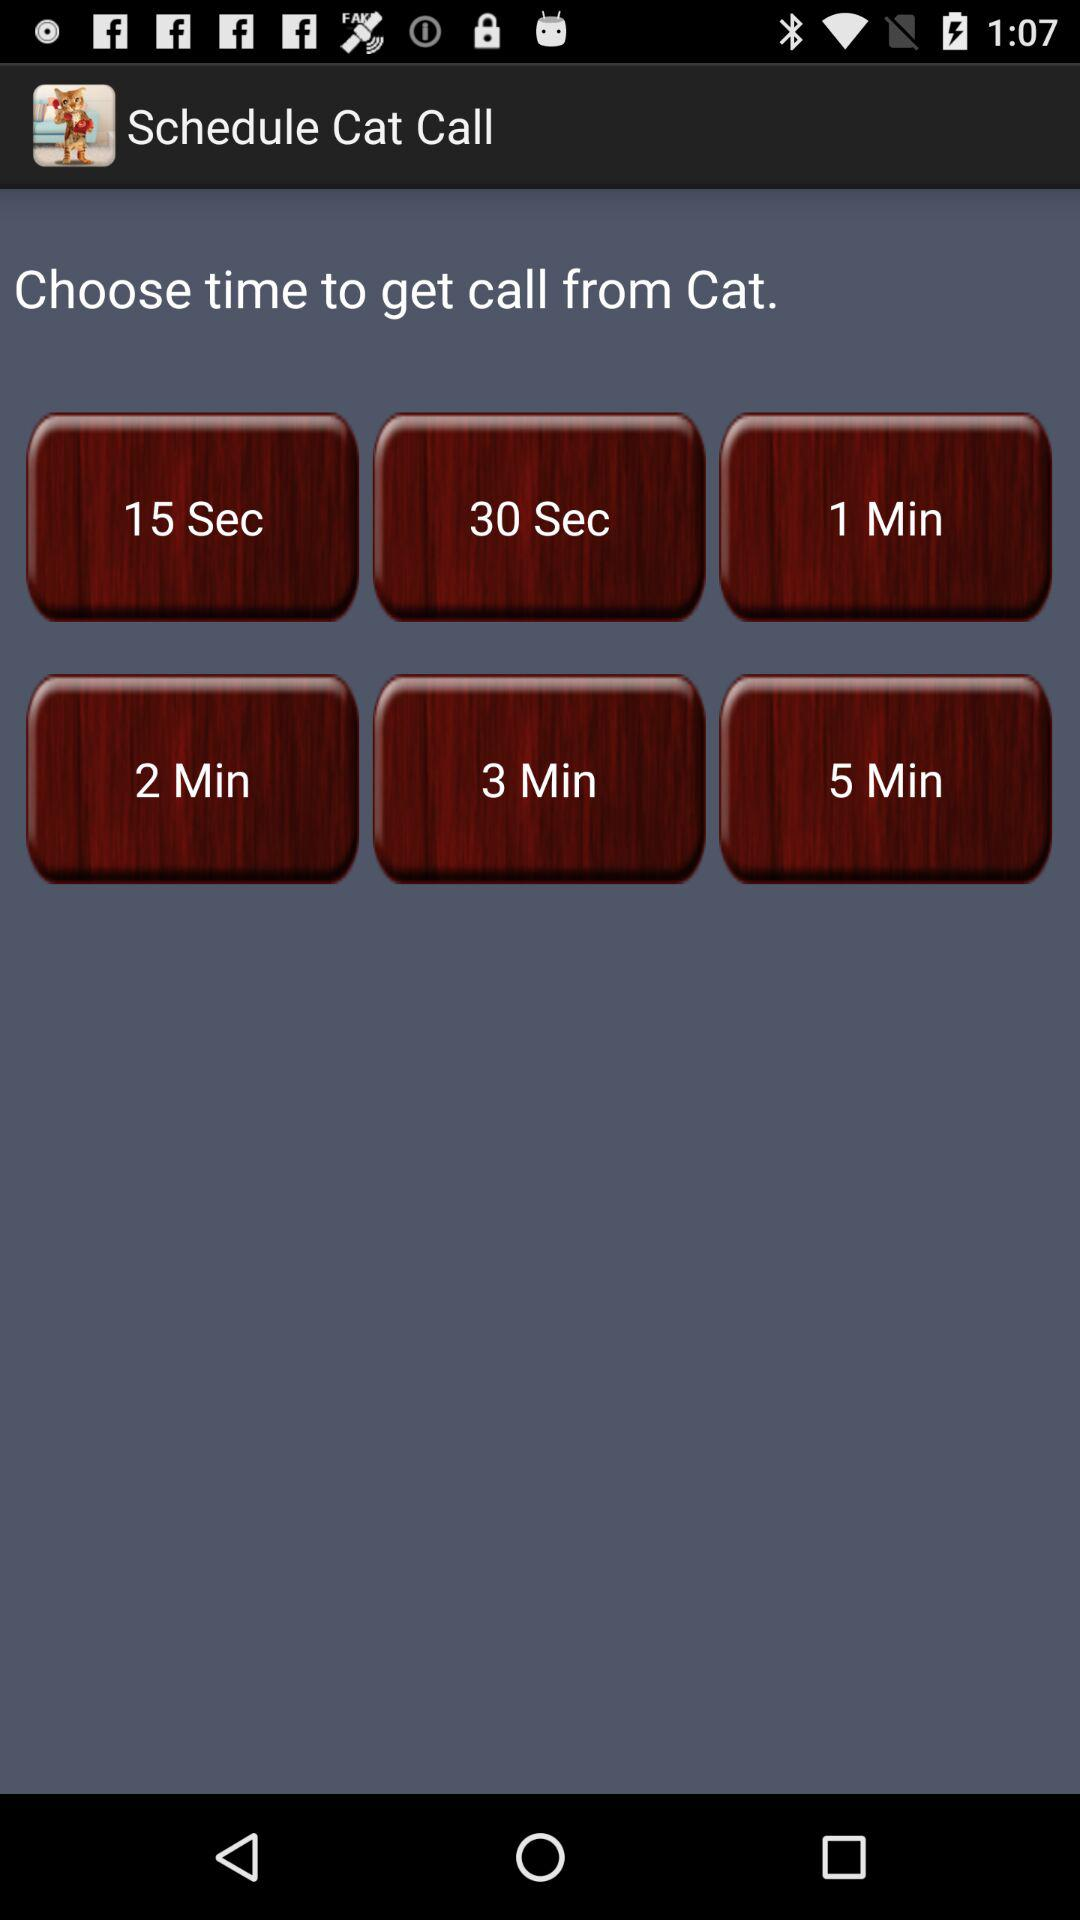How many more minutes is the 5 min call than the 1 min call?
Answer the question using a single word or phrase. 4 